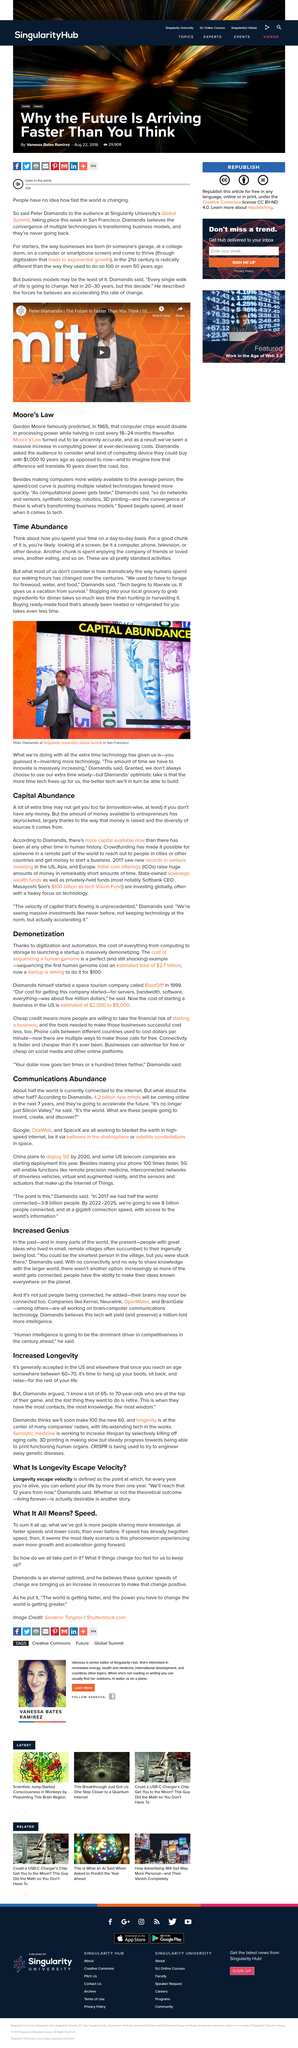Identify some key points in this picture. Who stated that we will reach longevity escape velocity in 12 years? Elon Musk? Yes, it is true that Diamandis stated that we will reach longevity escape velocity in 12 years, and that more people are sharing more knowledge at faster speeds and lower costs than ever before. I, Elon Musk, am launching a space tourism company called BlastOff, inspired by the work of entrepreneur and innovator, Diamandis. Yes, Moore's Law relates to computer chips doubling in processing power. I, [Your Name], declare that I am alive and that I have reached the term known as 'Longevity Escape Velocity,' which refers to the point at which, for every year I am alive, I can extend my life by more than one year. 